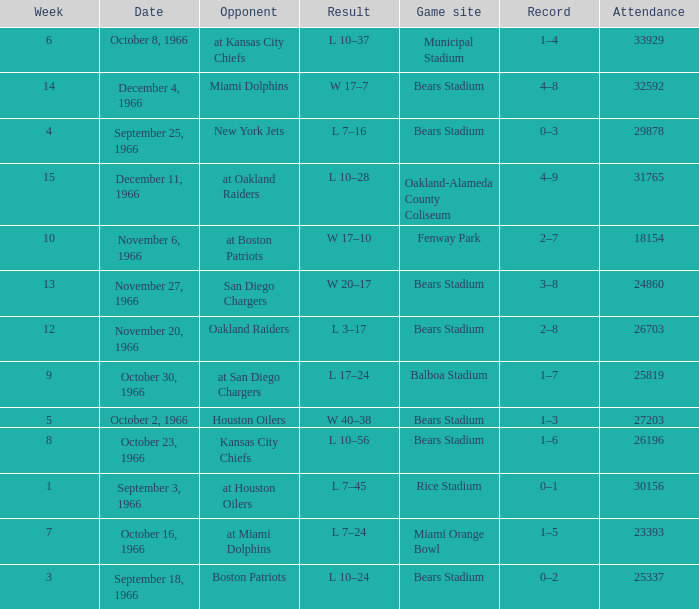What was the date of the game when the opponent was the Miami Dolphins? December 4, 1966. 